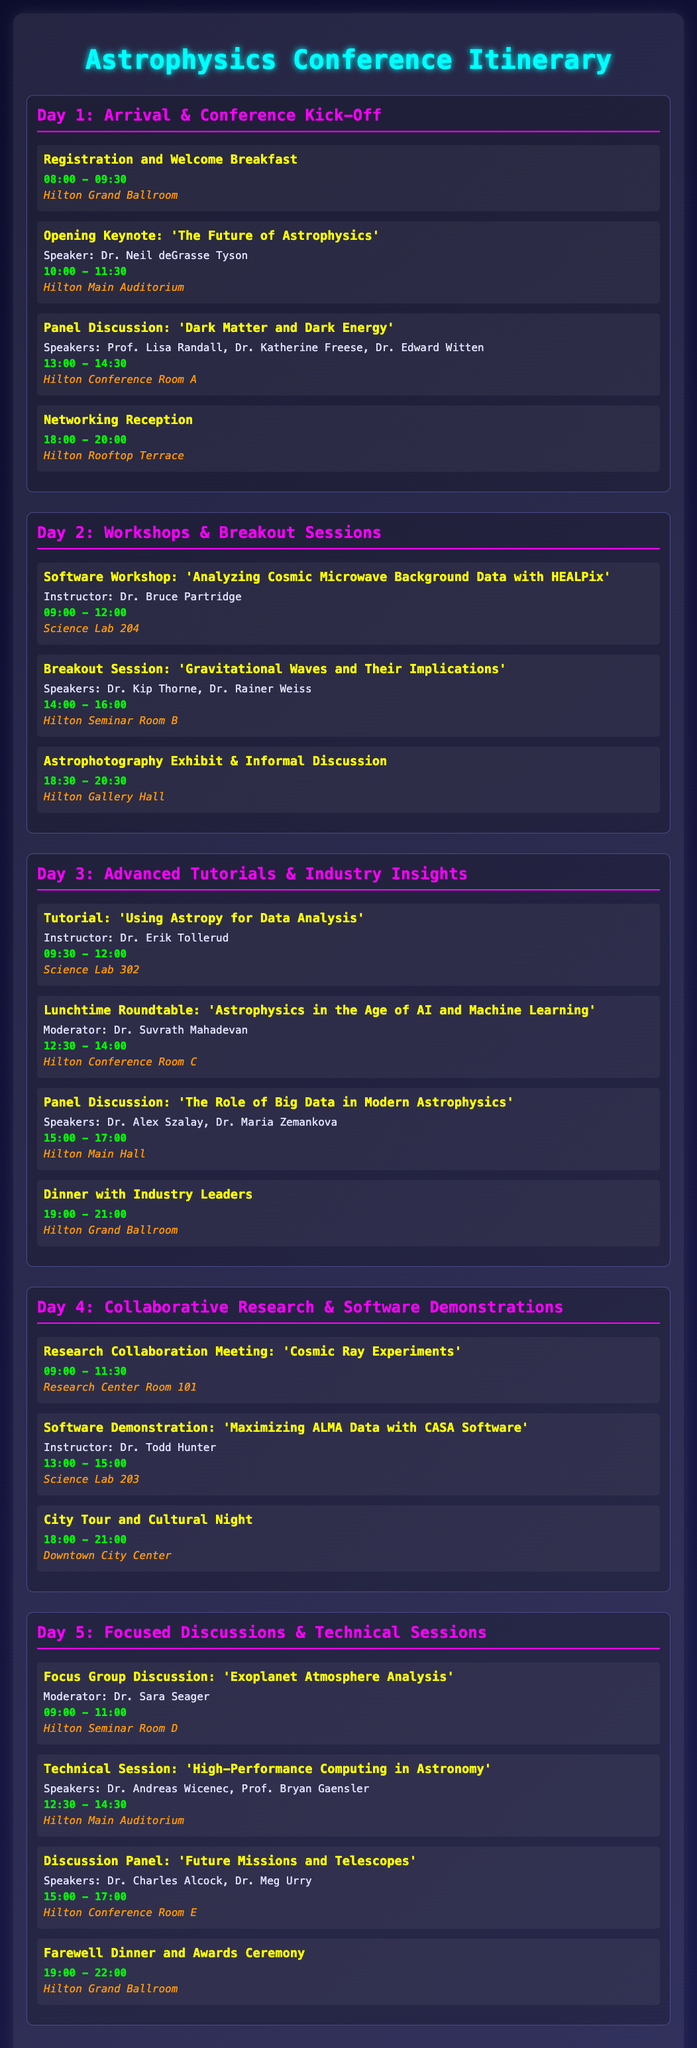What time does the conference kick off? The conference kick-off starts with registration and a welcome breakfast from 08:00 to 09:30.
Answer: 08:00 - 09:30 Who is the speaker for the opening keynote? The opening keynote is presented by Dr. Neil deGrasse Tyson.
Answer: Dr. Neil deGrasse Tyson Which day features a software workshop on analyzing CMB data? The software workshop on analyzing Cosmic Microwave Background Data with HEALPix takes place on Day 2.
Answer: Day 2 What is the location for the panel discussion on dark matter? The panel discussion on 'Dark Matter and Dark Energy' is held in Hilton Conference Room A.
Answer: Hilton Conference Room A How many events are scheduled for Day 3? There are four events scheduled for Day 3, including a tutorial, a roundtable, a panel discussion, and a dinner.
Answer: Four events Which dinner event occurs on Day 5? The farewell dinner and awards ceremony occur on Day 5.
Answer: Farewell Dinner and Awards Ceremony Who moderates the focus group discussion on exoplanet analysis? Dr. Sara Seager moderates the focus group discussion on 'Exoplanet Atmosphere Analysis'.
Answer: Dr. Sara Seager What time is the networking reception on Day 1? The networking reception takes place from 18:00 to 20:00 on Day 1.
Answer: 18:00 - 20:00 